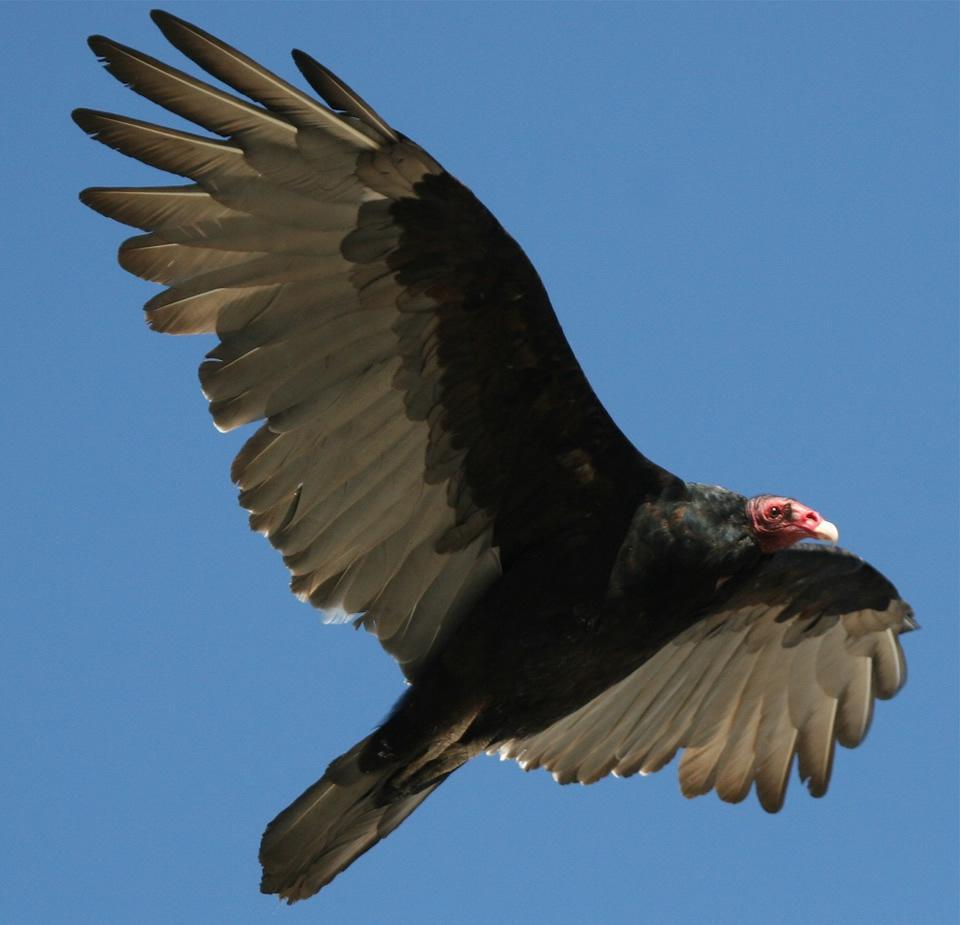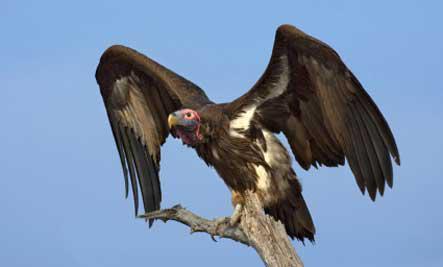The first image is the image on the left, the second image is the image on the right. Examine the images to the left and right. Is the description "A branch is visible only in the right image of a vulture." accurate? Answer yes or no. Yes. 